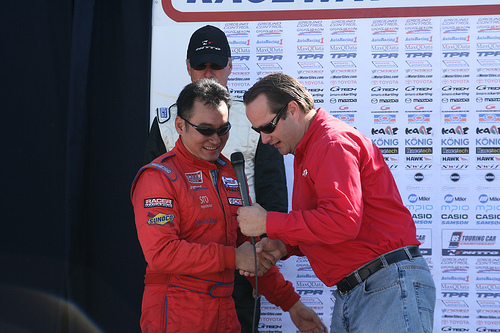<image>
Can you confirm if the man is to the left of the man? Yes. From this viewpoint, the man is positioned to the left side relative to the man. 